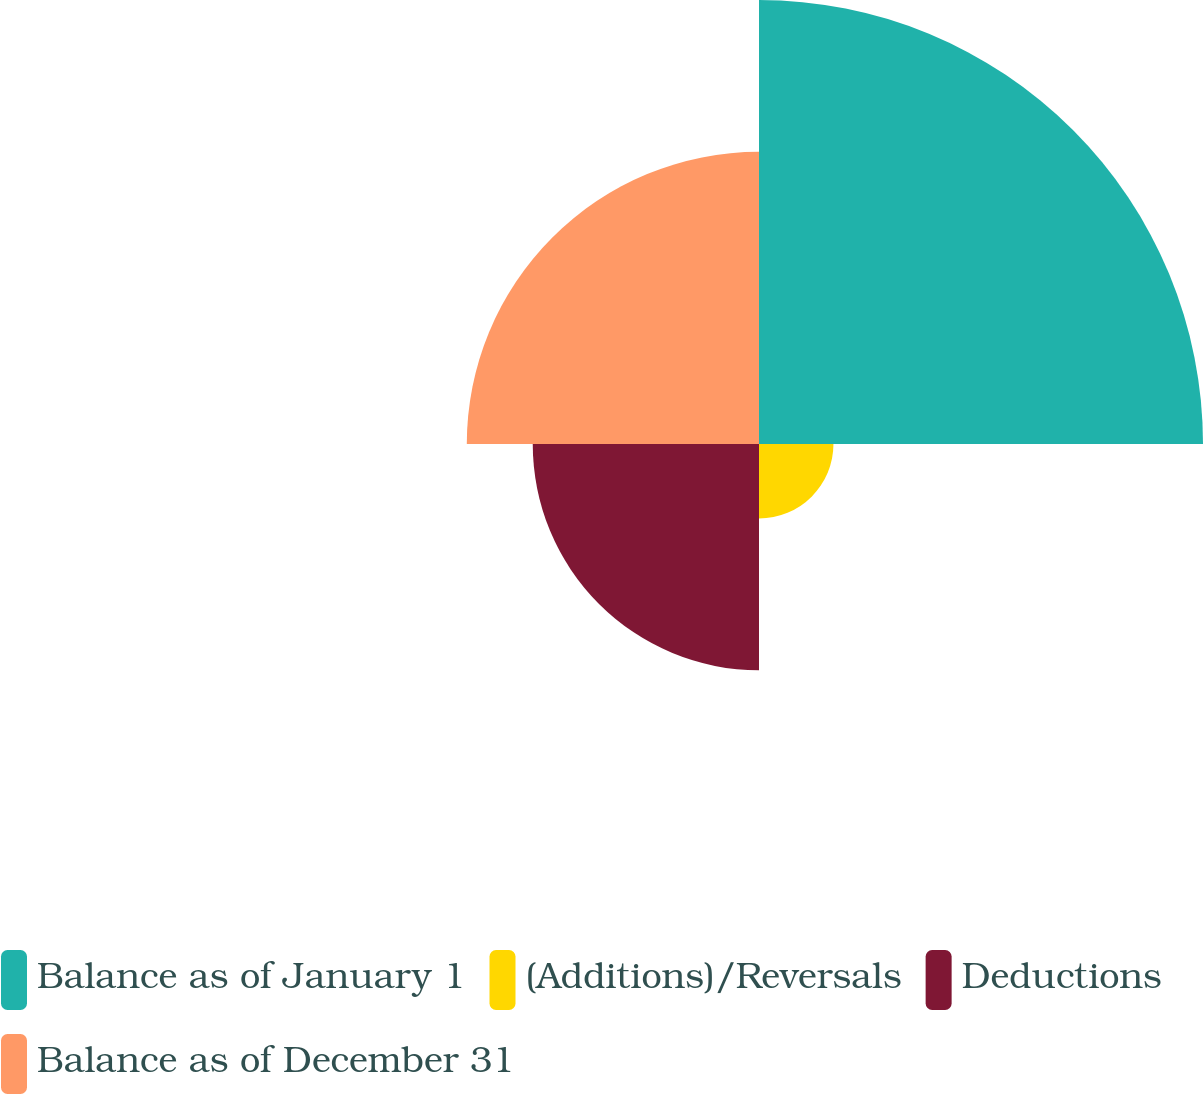Convert chart to OTSL. <chart><loc_0><loc_0><loc_500><loc_500><pie_chart><fcel>Balance as of January 1<fcel>(Additions)/Reversals<fcel>Deductions<fcel>Balance as of December 31<nl><fcel>42.82%<fcel>7.18%<fcel>21.82%<fcel>28.18%<nl></chart> 